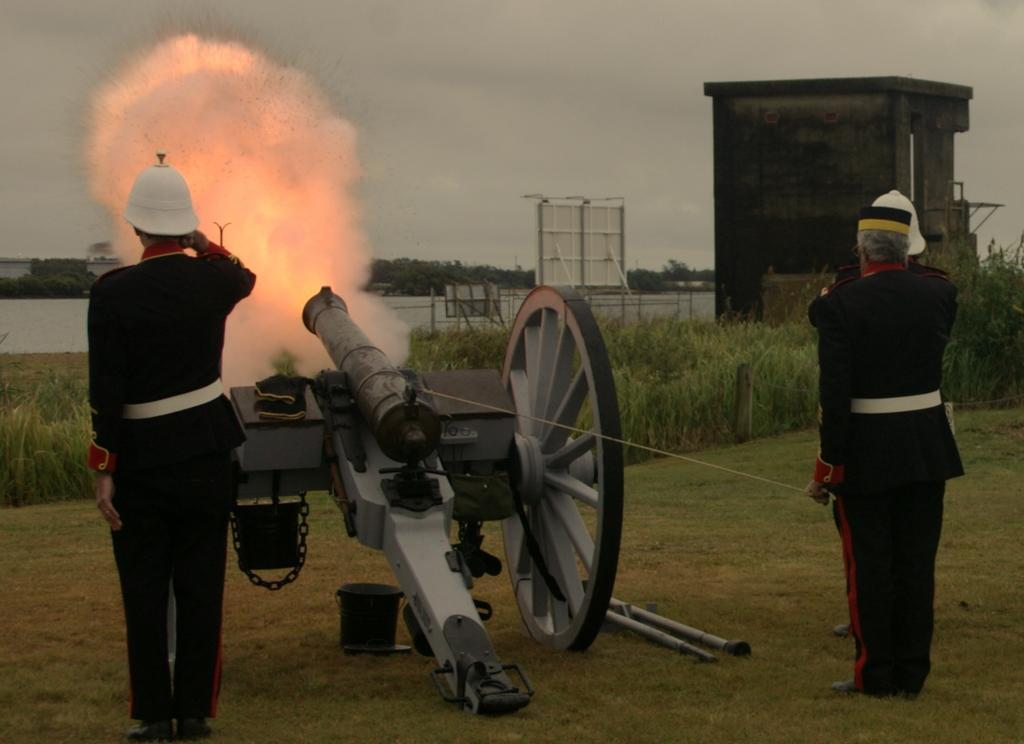Describe this image in one or two sentences. In this picture we can see people and a cannon on the ground and in the background we can see fire, trees, plants, shed, skye and some objects. 